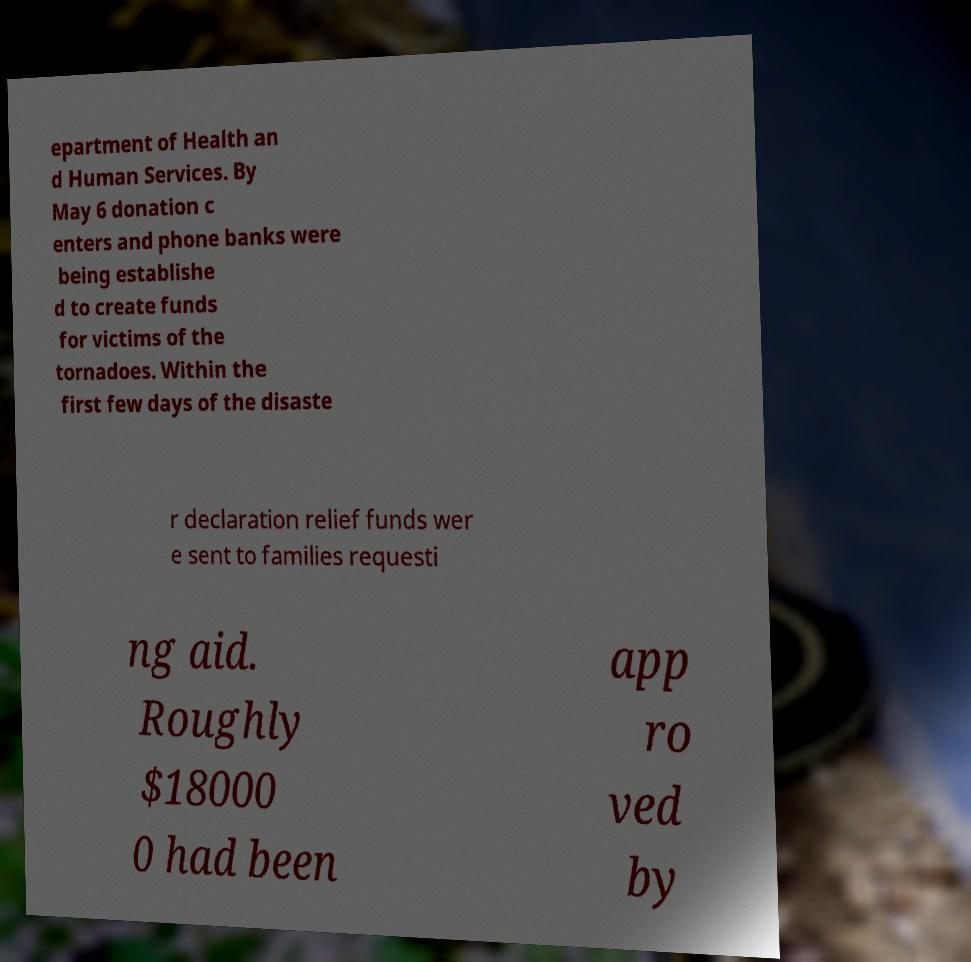Please read and relay the text visible in this image. What does it say? epartment of Health an d Human Services. By May 6 donation c enters and phone banks were being establishe d to create funds for victims of the tornadoes. Within the first few days of the disaste r declaration relief funds wer e sent to families requesti ng aid. Roughly $18000 0 had been app ro ved by 